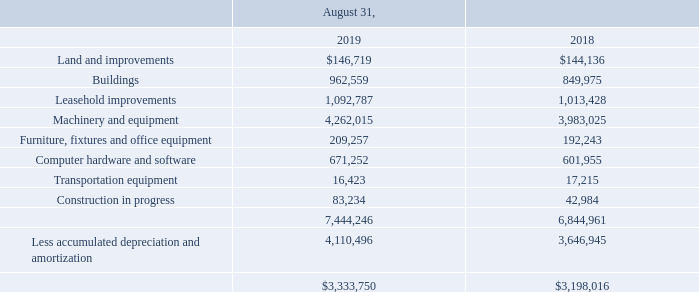5. Property, Plant and Equipment
Property, plant and equipment consists of the following (in thousands):
What were the land and improvements in 2019?
Answer scale should be: thousand. $146,719. What was the value of buildings in 2018?
Answer scale should be: thousand. 849,975. Which years does the table provide information for Property, plant and equipment? 2019, 2018. In 2019, how many property, plant and equipment exceeded $1,000,000 thousand? Machinery and equipment##Leasehold improvements
Answer: 2. What was the change in the amount of land and improvements between 2018 and 2019?
Answer scale should be: thousand. $146,719-$144,136
Answer: 2583. What was the percentage change in total property, plant and equipment between 2018 and 2019?
Answer scale should be: percent. ($3,333,750-$3,198,016)/$3,198,016
Answer: 4.24. 